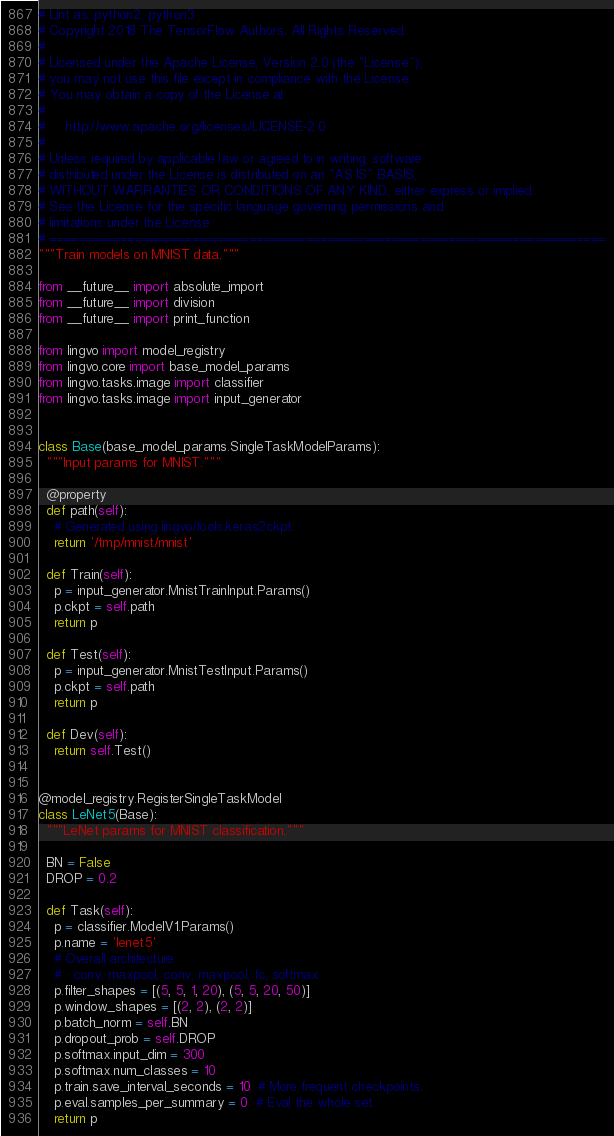<code> <loc_0><loc_0><loc_500><loc_500><_Python_># Lint as: python2, python3
# Copyright 2018 The TensorFlow Authors. All Rights Reserved.
#
# Licensed under the Apache License, Version 2.0 (the "License");
# you may not use this file except in compliance with the License.
# You may obtain a copy of the License at
#
#     http://www.apache.org/licenses/LICENSE-2.0
#
# Unless required by applicable law or agreed to in writing, software
# distributed under the License is distributed on an "AS IS" BASIS,
# WITHOUT WARRANTIES OR CONDITIONS OF ANY KIND, either express or implied.
# See the License for the specific language governing permissions and
# limitations under the License.
# ==============================================================================
"""Train models on MNIST data."""

from __future__ import absolute_import
from __future__ import division
from __future__ import print_function

from lingvo import model_registry
from lingvo.core import base_model_params
from lingvo.tasks.image import classifier
from lingvo.tasks.image import input_generator


class Base(base_model_params.SingleTaskModelParams):
  """Input params for MNIST."""

  @property
  def path(self):
    # Generated using lingvo/tools:keras2ckpt.
    return '/tmp/mnist/mnist'

  def Train(self):
    p = input_generator.MnistTrainInput.Params()
    p.ckpt = self.path
    return p

  def Test(self):
    p = input_generator.MnistTestInput.Params()
    p.ckpt = self.path
    return p

  def Dev(self):
    return self.Test()


@model_registry.RegisterSingleTaskModel
class LeNet5(Base):
  """LeNet params for MNIST classification."""

  BN = False
  DROP = 0.2

  def Task(self):
    p = classifier.ModelV1.Params()
    p.name = 'lenet5'
    # Overall architecture:
    #   conv, maxpool, conv, maxpool, fc, softmax.
    p.filter_shapes = [(5, 5, 1, 20), (5, 5, 20, 50)]
    p.window_shapes = [(2, 2), (2, 2)]
    p.batch_norm = self.BN
    p.dropout_prob = self.DROP
    p.softmax.input_dim = 300
    p.softmax.num_classes = 10
    p.train.save_interval_seconds = 10  # More frequent checkpoints.
    p.eval.samples_per_summary = 0  # Eval the whole set.
    return p
</code> 